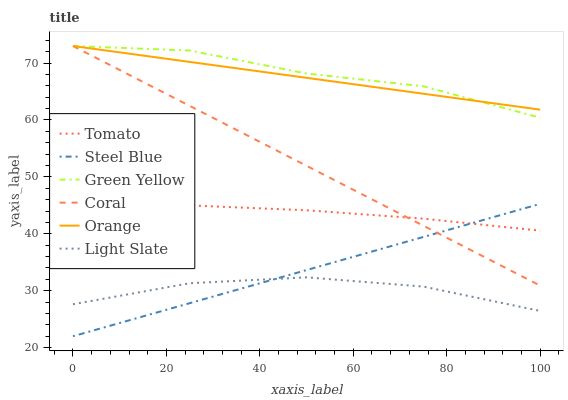Does Light Slate have the minimum area under the curve?
Answer yes or no. Yes. Does Green Yellow have the maximum area under the curve?
Answer yes or no. Yes. Does Coral have the minimum area under the curve?
Answer yes or no. No. Does Coral have the maximum area under the curve?
Answer yes or no. No. Is Coral the smoothest?
Answer yes or no. Yes. Is Green Yellow the roughest?
Answer yes or no. Yes. Is Light Slate the smoothest?
Answer yes or no. No. Is Light Slate the roughest?
Answer yes or no. No. Does Light Slate have the lowest value?
Answer yes or no. No. Does Green Yellow have the highest value?
Answer yes or no. Yes. Does Light Slate have the highest value?
Answer yes or no. No. Is Steel Blue less than Orange?
Answer yes or no. Yes. Is Coral greater than Light Slate?
Answer yes or no. Yes. Does Orange intersect Green Yellow?
Answer yes or no. Yes. Is Orange less than Green Yellow?
Answer yes or no. No. Is Orange greater than Green Yellow?
Answer yes or no. No. Does Steel Blue intersect Orange?
Answer yes or no. No. 